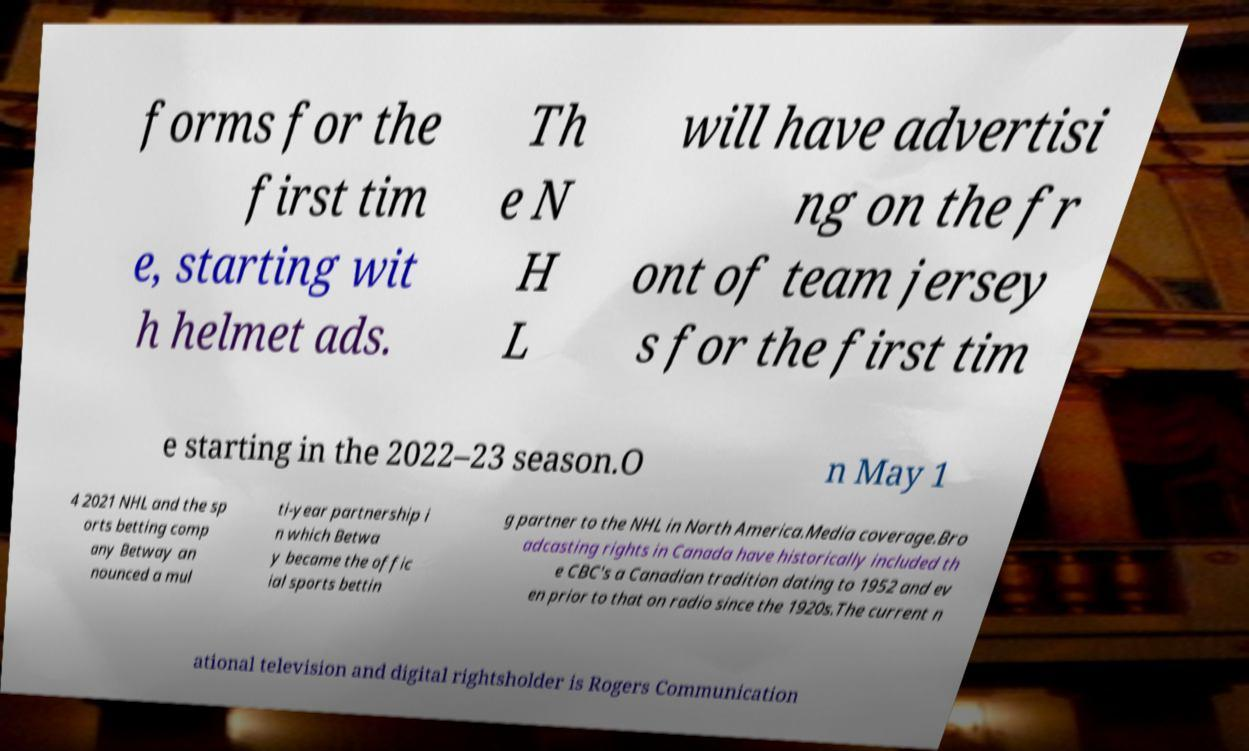There's text embedded in this image that I need extracted. Can you transcribe it verbatim? forms for the first tim e, starting wit h helmet ads. Th e N H L will have advertisi ng on the fr ont of team jersey s for the first tim e starting in the 2022–23 season.O n May 1 4 2021 NHL and the sp orts betting comp any Betway an nounced a mul ti-year partnership i n which Betwa y became the offic ial sports bettin g partner to the NHL in North America.Media coverage.Bro adcasting rights in Canada have historically included th e CBC's a Canadian tradition dating to 1952 and ev en prior to that on radio since the 1920s.The current n ational television and digital rightsholder is Rogers Communication 